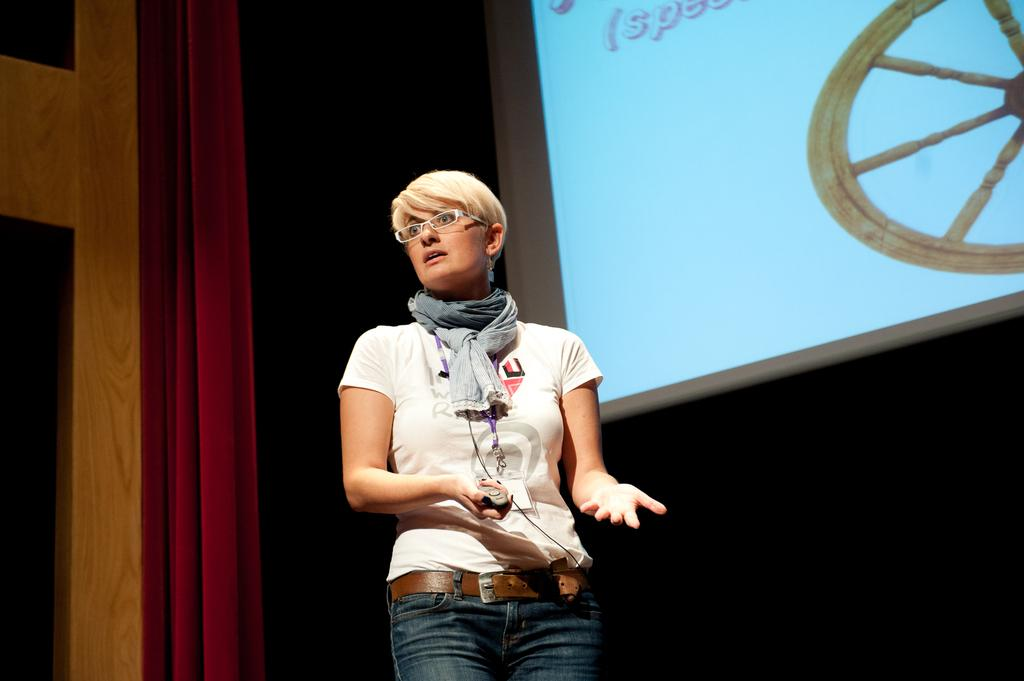Who is the main subject in the image? There is a woman in the image. Where is the woman located? The woman is standing on a stage. What can be seen in the background of the image? There is a screen and a red curtain in the background of the image. What instrument is the woman's father playing in the image? There is no father or instrument present in the image. 